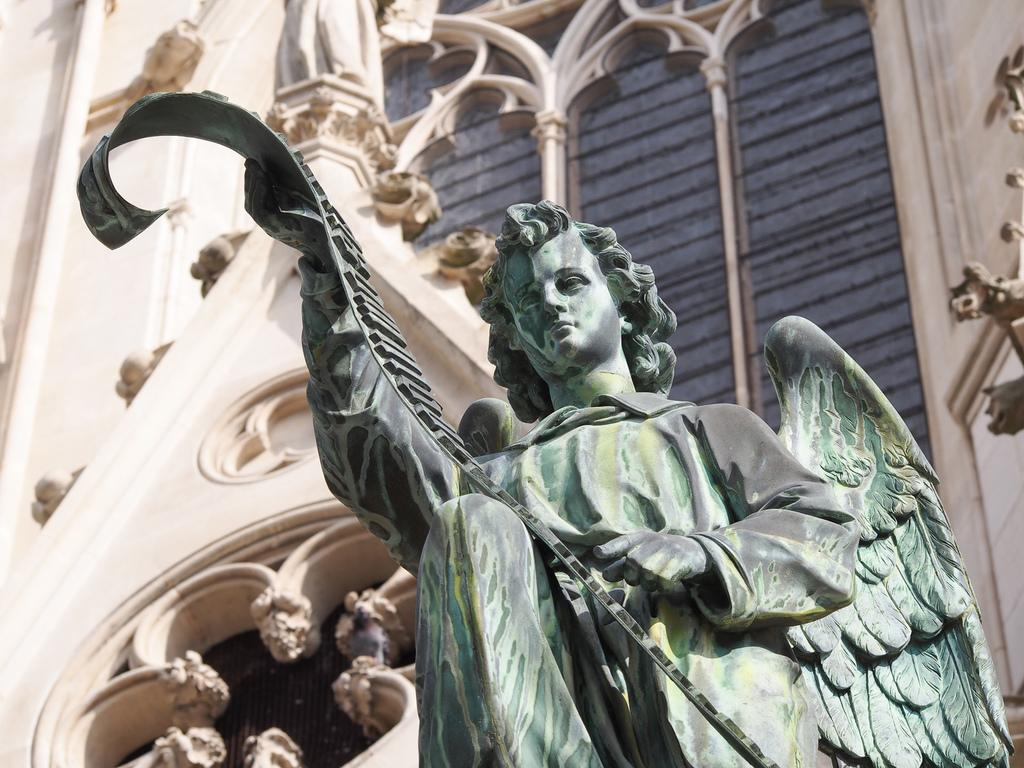What is the main subject of the image? There is a sculpture of a person in the image. What can be seen in the background of the image? There is a building in the background of the image. What is unique about the building in the image? The building has art designs on it. What type of boot is the person wearing in the image? There is no person wearing a boot in the image, as the main subject is a sculpture of a person. 